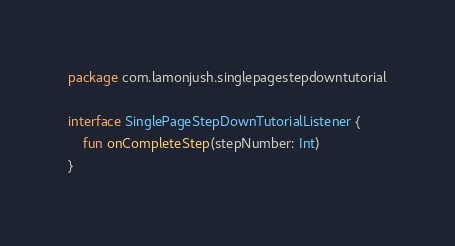Convert code to text. <code><loc_0><loc_0><loc_500><loc_500><_Kotlin_>package com.lamonjush.singlepagestepdowntutorial

interface SinglePageStepDownTutorialListener {
    fun onCompleteStep(stepNumber: Int)
}</code> 